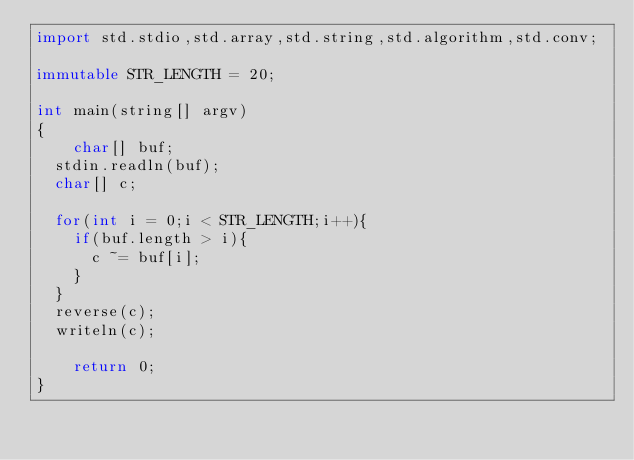Convert code to text. <code><loc_0><loc_0><loc_500><loc_500><_D_>import std.stdio,std.array,std.string,std.algorithm,std.conv;

immutable STR_LENGTH = 20;

int main(string[] argv)
{
    char[] buf;
	stdin.readln(buf);
	char[] c;

	for(int i = 0;i < STR_LENGTH;i++){
		if(buf.length > i){
			c ~= buf[i];
		}
	}
	reverse(c);
	writeln(c);

    return 0;
}</code> 